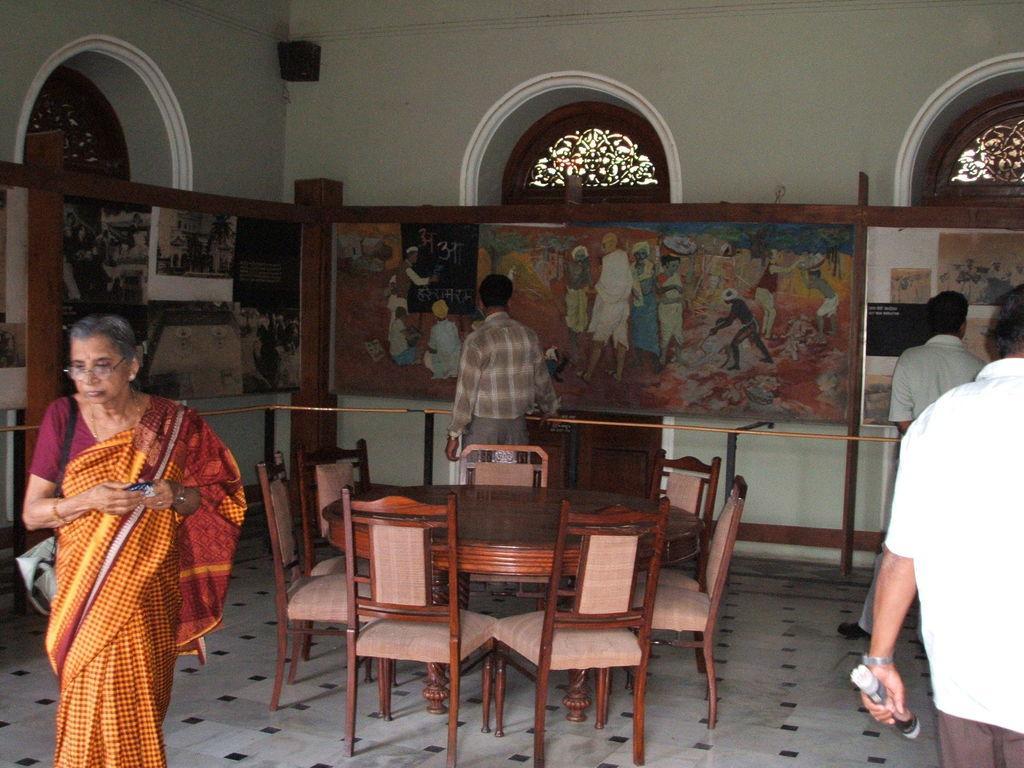Describe this image in one or two sentences. In the middle of an image there are chairs with dining table. Left a woman is walking here there are pictures and it's a wall. 